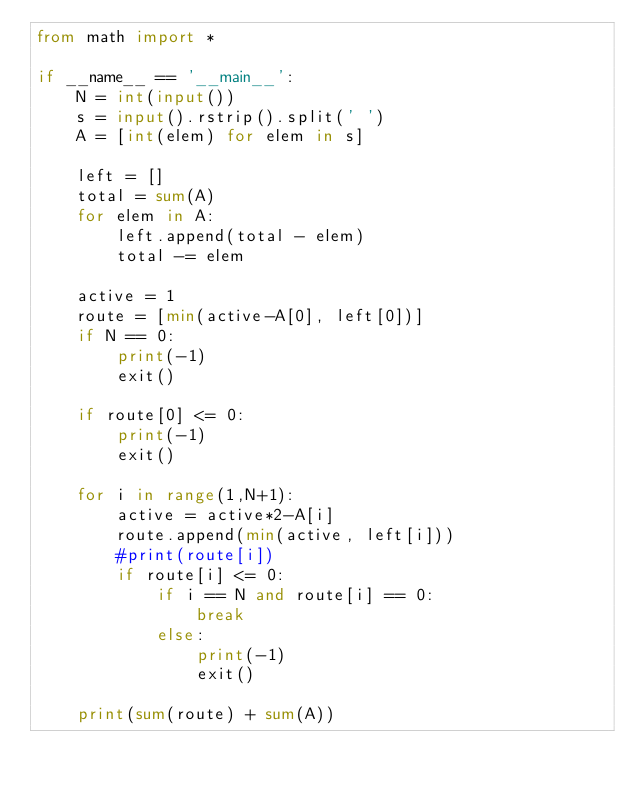<code> <loc_0><loc_0><loc_500><loc_500><_Python_>from math import *

if __name__ == '__main__':
    N = int(input())
    s = input().rstrip().split(' ')
    A = [int(elem) for elem in s]

    left = []
    total = sum(A)
    for elem in A:
        left.append(total - elem)
        total -= elem

    active = 1
    route = [min(active-A[0], left[0])]
    if N == 0:
        print(-1)
        exit()

    if route[0] <= 0: 
        print(-1)
        exit()

    for i in range(1,N+1):
        active = active*2-A[i]
        route.append(min(active, left[i]))
        #print(route[i])
        if route[i] <= 0: 
            if i == N and route[i] == 0:
                break
            else:
                print(-1)
                exit()

    print(sum(route) + sum(A))</code> 